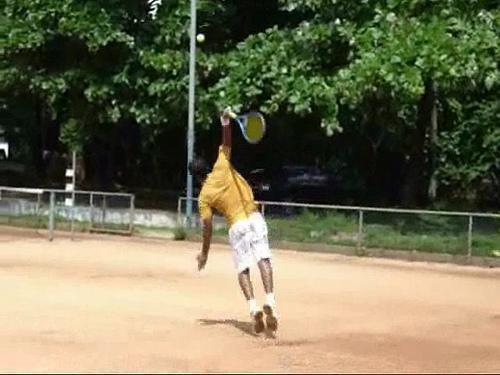The player is using all his energy when preparing to do what with the ball?
Answer the question by selecting the correct answer among the 4 following choices.
Options: Bunce it, throw it, roll it, serve it. Serve it. 